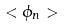Convert formula to latex. <formula><loc_0><loc_0><loc_500><loc_500>< \phi _ { n } ></formula> 